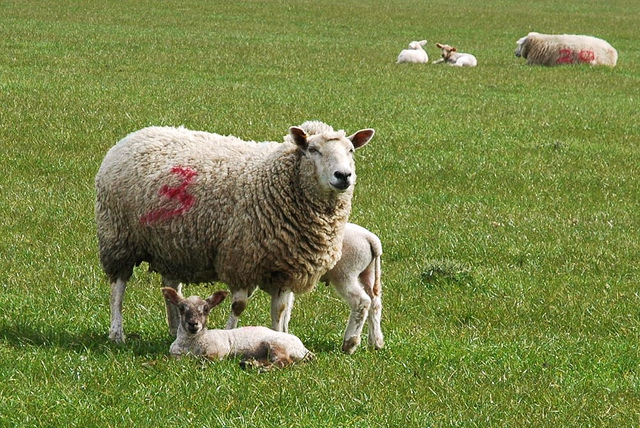<image>Who sprayed the sheep? I don't know who sprayed the sheep. It could be the farmer or the owner. Who sprayed the sheep? I don't know who sprayed the sheep. It can be seen that the farmer probably sprayed the sheep. 